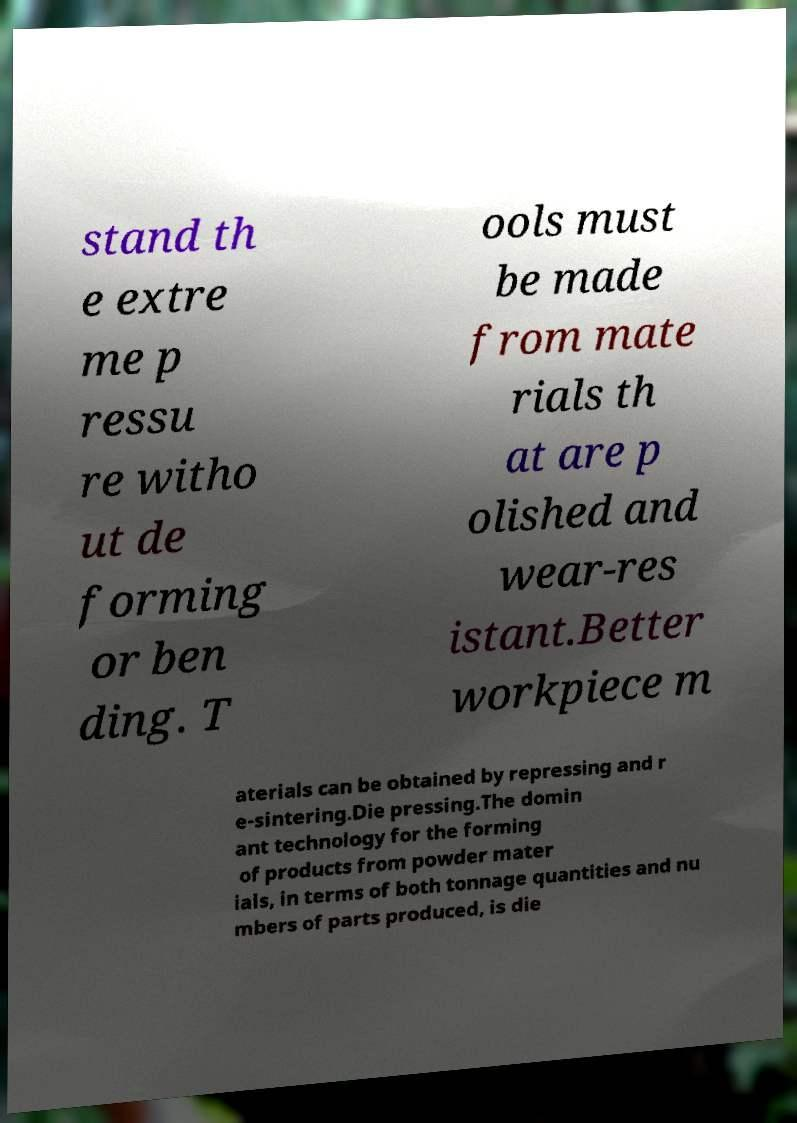There's text embedded in this image that I need extracted. Can you transcribe it verbatim? stand th e extre me p ressu re witho ut de forming or ben ding. T ools must be made from mate rials th at are p olished and wear-res istant.Better workpiece m aterials can be obtained by repressing and r e-sintering.Die pressing.The domin ant technology for the forming of products from powder mater ials, in terms of both tonnage quantities and nu mbers of parts produced, is die 